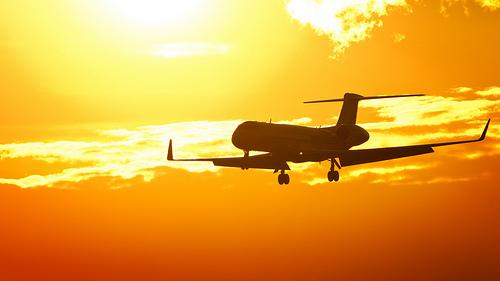Question: when was the photo taken?
Choices:
A. On the ground.
B. Before takeoff.
C. During flight.
D. After landing.
Answer with the letter. Answer: C Question: why is the sky orange?
Choices:
A. Air pollution.
B. You're wearing sunglasses.
C. You're high.
D. The sun is shining.
Answer with the letter. Answer: D Question: what is flying?
Choices:
A. An airplane.
B. A helicopter.
C. A kite.
D. A glider.
Answer with the letter. Answer: A Question: who is controlling the plane?
Choices:
A. The co-pilot.
B. The pilot.
C. The auto-pilot.
D. The stewardess.
Answer with the letter. Answer: B Question: what color is the sky?
Choices:
A. Blue.
B. Orange.
C. Light blue.
D. Magenta.
Answer with the letter. Answer: B 